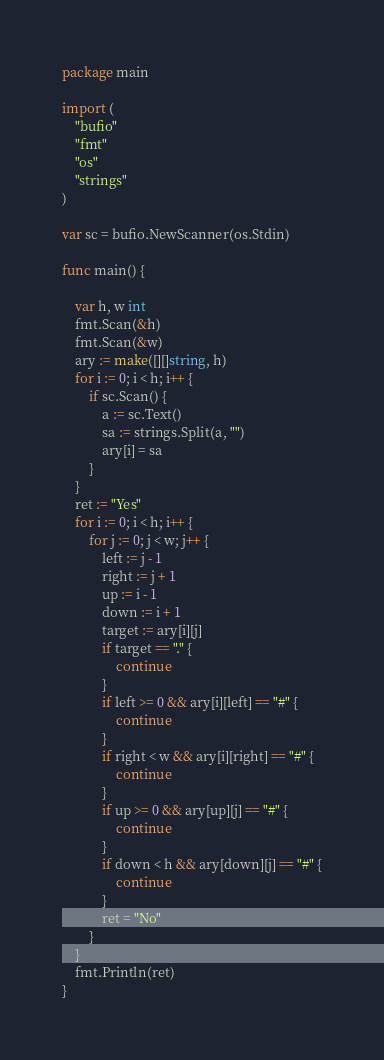<code> <loc_0><loc_0><loc_500><loc_500><_Go_>package main

import (
	"bufio"
	"fmt"
	"os"
	"strings"
)

var sc = bufio.NewScanner(os.Stdin)

func main() {

	var h, w int
	fmt.Scan(&h)
	fmt.Scan(&w)
	ary := make([][]string, h)
	for i := 0; i < h; i++ {
		if sc.Scan() {
			a := sc.Text()
			sa := strings.Split(a, "")
			ary[i] = sa
		}
	}
	ret := "Yes"
	for i := 0; i < h; i++ {
		for j := 0; j < w; j++ {
			left := j - 1
			right := j + 1
			up := i - 1
			down := i + 1
			target := ary[i][j]
			if target == "." {
				continue
			}
			if left >= 0 && ary[i][left] == "#" {
				continue
			}
			if right < w && ary[i][right] == "#" {
				continue
			}
			if up >= 0 && ary[up][j] == "#" {
				continue
			}
			if down < h && ary[down][j] == "#" {
				continue
			}
			ret = "No"
		}
	}
	fmt.Println(ret)
}
</code> 